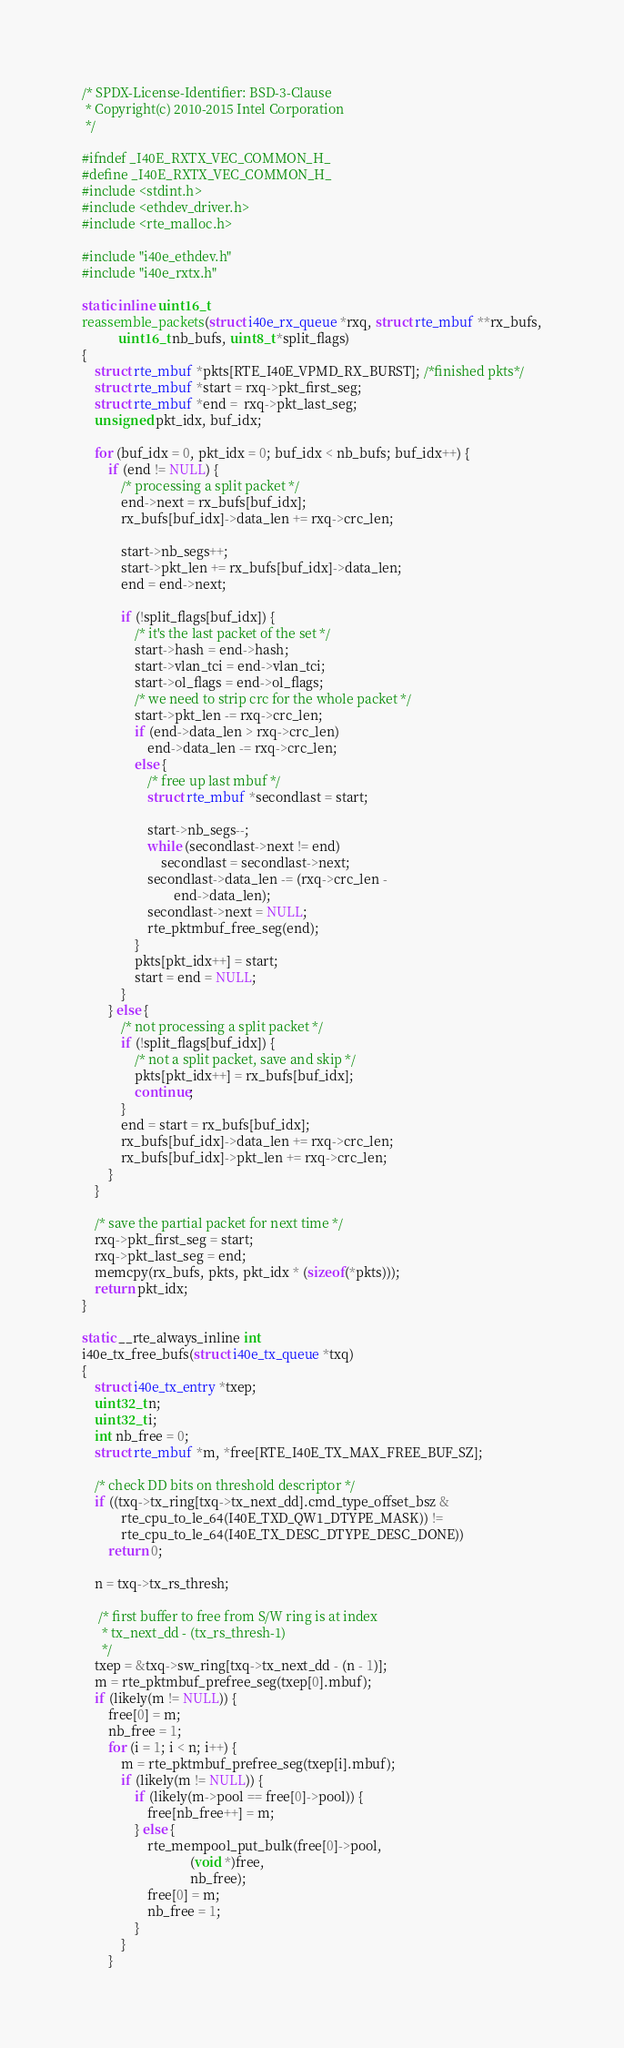<code> <loc_0><loc_0><loc_500><loc_500><_C_>/* SPDX-License-Identifier: BSD-3-Clause
 * Copyright(c) 2010-2015 Intel Corporation
 */

#ifndef _I40E_RXTX_VEC_COMMON_H_
#define _I40E_RXTX_VEC_COMMON_H_
#include <stdint.h>
#include <ethdev_driver.h>
#include <rte_malloc.h>

#include "i40e_ethdev.h"
#include "i40e_rxtx.h"

static inline uint16_t
reassemble_packets(struct i40e_rx_queue *rxq, struct rte_mbuf **rx_bufs,
		   uint16_t nb_bufs, uint8_t *split_flags)
{
	struct rte_mbuf *pkts[RTE_I40E_VPMD_RX_BURST]; /*finished pkts*/
	struct rte_mbuf *start = rxq->pkt_first_seg;
	struct rte_mbuf *end =  rxq->pkt_last_seg;
	unsigned pkt_idx, buf_idx;

	for (buf_idx = 0, pkt_idx = 0; buf_idx < nb_bufs; buf_idx++) {
		if (end != NULL) {
			/* processing a split packet */
			end->next = rx_bufs[buf_idx];
			rx_bufs[buf_idx]->data_len += rxq->crc_len;

			start->nb_segs++;
			start->pkt_len += rx_bufs[buf_idx]->data_len;
			end = end->next;

			if (!split_flags[buf_idx]) {
				/* it's the last packet of the set */
				start->hash = end->hash;
				start->vlan_tci = end->vlan_tci;
				start->ol_flags = end->ol_flags;
				/* we need to strip crc for the whole packet */
				start->pkt_len -= rxq->crc_len;
				if (end->data_len > rxq->crc_len)
					end->data_len -= rxq->crc_len;
				else {
					/* free up last mbuf */
					struct rte_mbuf *secondlast = start;

					start->nb_segs--;
					while (secondlast->next != end)
						secondlast = secondlast->next;
					secondlast->data_len -= (rxq->crc_len -
							end->data_len);
					secondlast->next = NULL;
					rte_pktmbuf_free_seg(end);
				}
				pkts[pkt_idx++] = start;
				start = end = NULL;
			}
		} else {
			/* not processing a split packet */
			if (!split_flags[buf_idx]) {
				/* not a split packet, save and skip */
				pkts[pkt_idx++] = rx_bufs[buf_idx];
				continue;
			}
			end = start = rx_bufs[buf_idx];
			rx_bufs[buf_idx]->data_len += rxq->crc_len;
			rx_bufs[buf_idx]->pkt_len += rxq->crc_len;
		}
	}

	/* save the partial packet for next time */
	rxq->pkt_first_seg = start;
	rxq->pkt_last_seg = end;
	memcpy(rx_bufs, pkts, pkt_idx * (sizeof(*pkts)));
	return pkt_idx;
}

static __rte_always_inline int
i40e_tx_free_bufs(struct i40e_tx_queue *txq)
{
	struct i40e_tx_entry *txep;
	uint32_t n;
	uint32_t i;
	int nb_free = 0;
	struct rte_mbuf *m, *free[RTE_I40E_TX_MAX_FREE_BUF_SZ];

	/* check DD bits on threshold descriptor */
	if ((txq->tx_ring[txq->tx_next_dd].cmd_type_offset_bsz &
			rte_cpu_to_le_64(I40E_TXD_QW1_DTYPE_MASK)) !=
			rte_cpu_to_le_64(I40E_TX_DESC_DTYPE_DESC_DONE))
		return 0;

	n = txq->tx_rs_thresh;

	 /* first buffer to free from S/W ring is at index
	  * tx_next_dd - (tx_rs_thresh-1)
	  */
	txep = &txq->sw_ring[txq->tx_next_dd - (n - 1)];
	m = rte_pktmbuf_prefree_seg(txep[0].mbuf);
	if (likely(m != NULL)) {
		free[0] = m;
		nb_free = 1;
		for (i = 1; i < n; i++) {
			m = rte_pktmbuf_prefree_seg(txep[i].mbuf);
			if (likely(m != NULL)) {
				if (likely(m->pool == free[0]->pool)) {
					free[nb_free++] = m;
				} else {
					rte_mempool_put_bulk(free[0]->pool,
							     (void *)free,
							     nb_free);
					free[0] = m;
					nb_free = 1;
				}
			}
		}</code> 